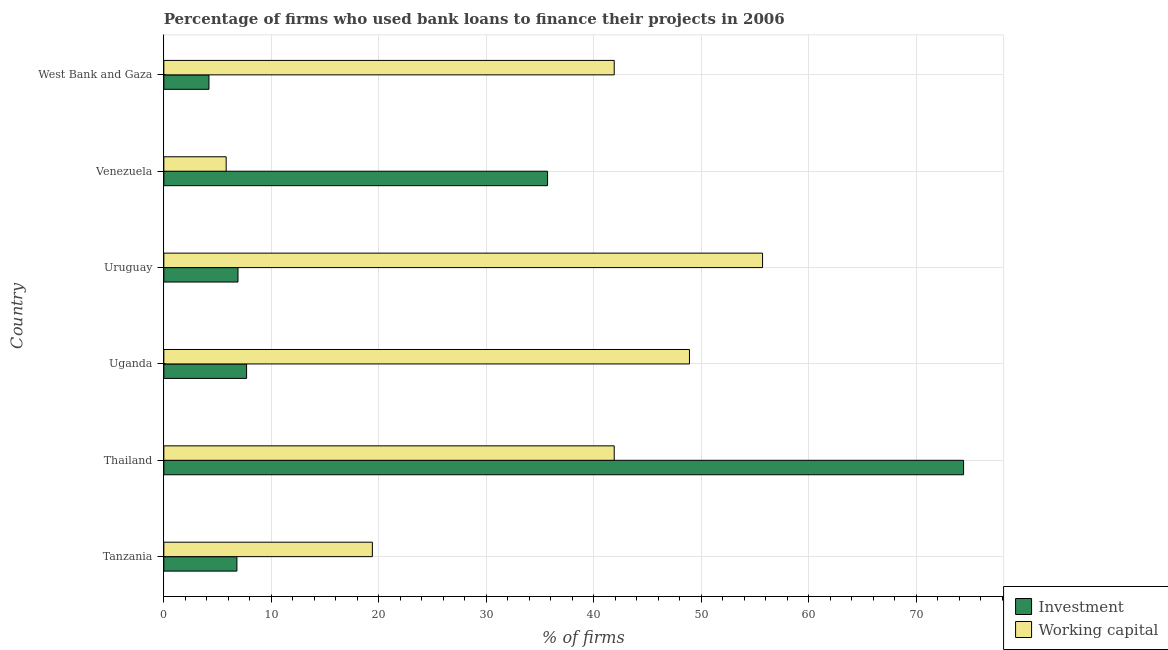Are the number of bars per tick equal to the number of legend labels?
Your answer should be very brief. Yes. How many bars are there on the 6th tick from the top?
Ensure brevity in your answer.  2. How many bars are there on the 2nd tick from the bottom?
Provide a succinct answer. 2. What is the label of the 4th group of bars from the top?
Your answer should be compact. Uganda. In how many cases, is the number of bars for a given country not equal to the number of legend labels?
Provide a short and direct response. 0. What is the percentage of firms using banks to finance investment in Thailand?
Your response must be concise. 74.4. Across all countries, what is the maximum percentage of firms using banks to finance working capital?
Your answer should be compact. 55.7. In which country was the percentage of firms using banks to finance working capital maximum?
Your answer should be very brief. Uruguay. In which country was the percentage of firms using banks to finance investment minimum?
Your response must be concise. West Bank and Gaza. What is the total percentage of firms using banks to finance investment in the graph?
Ensure brevity in your answer.  135.7. What is the difference between the percentage of firms using banks to finance investment in Thailand and that in West Bank and Gaza?
Provide a succinct answer. 70.2. What is the difference between the percentage of firms using banks to finance investment in Uruguay and the percentage of firms using banks to finance working capital in Thailand?
Your response must be concise. -35. What is the average percentage of firms using banks to finance investment per country?
Your answer should be very brief. 22.62. What is the difference between the percentage of firms using banks to finance working capital and percentage of firms using banks to finance investment in Uruguay?
Ensure brevity in your answer.  48.8. In how many countries, is the percentage of firms using banks to finance working capital greater than 20 %?
Provide a short and direct response. 4. What is the ratio of the percentage of firms using banks to finance working capital in Thailand to that in Venezuela?
Offer a terse response. 7.22. Is the percentage of firms using banks to finance working capital in Tanzania less than that in Uruguay?
Provide a succinct answer. Yes. Is the difference between the percentage of firms using banks to finance working capital in Tanzania and Thailand greater than the difference between the percentage of firms using banks to finance investment in Tanzania and Thailand?
Ensure brevity in your answer.  Yes. What is the difference between the highest and the second highest percentage of firms using banks to finance investment?
Your response must be concise. 38.7. What is the difference between the highest and the lowest percentage of firms using banks to finance working capital?
Your answer should be compact. 49.9. Is the sum of the percentage of firms using banks to finance working capital in Thailand and West Bank and Gaza greater than the maximum percentage of firms using banks to finance investment across all countries?
Make the answer very short. Yes. What does the 1st bar from the top in Tanzania represents?
Provide a short and direct response. Working capital. What does the 1st bar from the bottom in Tanzania represents?
Make the answer very short. Investment. Are all the bars in the graph horizontal?
Provide a short and direct response. Yes. Are the values on the major ticks of X-axis written in scientific E-notation?
Keep it short and to the point. No. Does the graph contain grids?
Keep it short and to the point. Yes. Where does the legend appear in the graph?
Your answer should be compact. Bottom right. How many legend labels are there?
Offer a very short reply. 2. How are the legend labels stacked?
Your answer should be compact. Vertical. What is the title of the graph?
Your answer should be compact. Percentage of firms who used bank loans to finance their projects in 2006. Does "Boys" appear as one of the legend labels in the graph?
Make the answer very short. No. What is the label or title of the X-axis?
Provide a succinct answer. % of firms. What is the label or title of the Y-axis?
Provide a succinct answer. Country. What is the % of firms of Investment in Tanzania?
Keep it short and to the point. 6.8. What is the % of firms of Investment in Thailand?
Your answer should be compact. 74.4. What is the % of firms of Working capital in Thailand?
Provide a succinct answer. 41.9. What is the % of firms of Working capital in Uganda?
Keep it short and to the point. 48.9. What is the % of firms of Working capital in Uruguay?
Your response must be concise. 55.7. What is the % of firms in Investment in Venezuela?
Keep it short and to the point. 35.7. What is the % of firms of Working capital in Venezuela?
Offer a very short reply. 5.8. What is the % of firms in Investment in West Bank and Gaza?
Offer a terse response. 4.2. What is the % of firms in Working capital in West Bank and Gaza?
Keep it short and to the point. 41.9. Across all countries, what is the maximum % of firms in Investment?
Make the answer very short. 74.4. Across all countries, what is the maximum % of firms in Working capital?
Your response must be concise. 55.7. Across all countries, what is the minimum % of firms in Working capital?
Provide a succinct answer. 5.8. What is the total % of firms of Investment in the graph?
Make the answer very short. 135.7. What is the total % of firms in Working capital in the graph?
Give a very brief answer. 213.6. What is the difference between the % of firms in Investment in Tanzania and that in Thailand?
Give a very brief answer. -67.6. What is the difference between the % of firms in Working capital in Tanzania and that in Thailand?
Keep it short and to the point. -22.5. What is the difference between the % of firms in Investment in Tanzania and that in Uganda?
Keep it short and to the point. -0.9. What is the difference between the % of firms of Working capital in Tanzania and that in Uganda?
Keep it short and to the point. -29.5. What is the difference between the % of firms of Investment in Tanzania and that in Uruguay?
Ensure brevity in your answer.  -0.1. What is the difference between the % of firms of Working capital in Tanzania and that in Uruguay?
Make the answer very short. -36.3. What is the difference between the % of firms in Investment in Tanzania and that in Venezuela?
Give a very brief answer. -28.9. What is the difference between the % of firms in Investment in Tanzania and that in West Bank and Gaza?
Your answer should be compact. 2.6. What is the difference between the % of firms of Working capital in Tanzania and that in West Bank and Gaza?
Keep it short and to the point. -22.5. What is the difference between the % of firms of Investment in Thailand and that in Uganda?
Your response must be concise. 66.7. What is the difference between the % of firms of Investment in Thailand and that in Uruguay?
Ensure brevity in your answer.  67.5. What is the difference between the % of firms of Investment in Thailand and that in Venezuela?
Provide a succinct answer. 38.7. What is the difference between the % of firms of Working capital in Thailand and that in Venezuela?
Provide a short and direct response. 36.1. What is the difference between the % of firms in Investment in Thailand and that in West Bank and Gaza?
Provide a short and direct response. 70.2. What is the difference between the % of firms of Working capital in Thailand and that in West Bank and Gaza?
Provide a short and direct response. 0. What is the difference between the % of firms in Investment in Uganda and that in Venezuela?
Make the answer very short. -28. What is the difference between the % of firms in Working capital in Uganda and that in Venezuela?
Provide a succinct answer. 43.1. What is the difference between the % of firms of Working capital in Uganda and that in West Bank and Gaza?
Ensure brevity in your answer.  7. What is the difference between the % of firms of Investment in Uruguay and that in Venezuela?
Ensure brevity in your answer.  -28.8. What is the difference between the % of firms in Working capital in Uruguay and that in Venezuela?
Ensure brevity in your answer.  49.9. What is the difference between the % of firms in Working capital in Uruguay and that in West Bank and Gaza?
Ensure brevity in your answer.  13.8. What is the difference between the % of firms of Investment in Venezuela and that in West Bank and Gaza?
Make the answer very short. 31.5. What is the difference between the % of firms of Working capital in Venezuela and that in West Bank and Gaza?
Offer a terse response. -36.1. What is the difference between the % of firms in Investment in Tanzania and the % of firms in Working capital in Thailand?
Offer a very short reply. -35.1. What is the difference between the % of firms in Investment in Tanzania and the % of firms in Working capital in Uganda?
Your answer should be very brief. -42.1. What is the difference between the % of firms in Investment in Tanzania and the % of firms in Working capital in Uruguay?
Make the answer very short. -48.9. What is the difference between the % of firms in Investment in Tanzania and the % of firms in Working capital in Venezuela?
Your answer should be very brief. 1. What is the difference between the % of firms in Investment in Tanzania and the % of firms in Working capital in West Bank and Gaza?
Your response must be concise. -35.1. What is the difference between the % of firms of Investment in Thailand and the % of firms of Working capital in Venezuela?
Give a very brief answer. 68.6. What is the difference between the % of firms of Investment in Thailand and the % of firms of Working capital in West Bank and Gaza?
Your answer should be very brief. 32.5. What is the difference between the % of firms of Investment in Uganda and the % of firms of Working capital in Uruguay?
Give a very brief answer. -48. What is the difference between the % of firms in Investment in Uganda and the % of firms in Working capital in Venezuela?
Offer a very short reply. 1.9. What is the difference between the % of firms in Investment in Uganda and the % of firms in Working capital in West Bank and Gaza?
Offer a very short reply. -34.2. What is the difference between the % of firms in Investment in Uruguay and the % of firms in Working capital in Venezuela?
Your answer should be compact. 1.1. What is the difference between the % of firms of Investment in Uruguay and the % of firms of Working capital in West Bank and Gaza?
Keep it short and to the point. -35. What is the difference between the % of firms in Investment in Venezuela and the % of firms in Working capital in West Bank and Gaza?
Make the answer very short. -6.2. What is the average % of firms of Investment per country?
Give a very brief answer. 22.62. What is the average % of firms of Working capital per country?
Give a very brief answer. 35.6. What is the difference between the % of firms of Investment and % of firms of Working capital in Thailand?
Provide a short and direct response. 32.5. What is the difference between the % of firms of Investment and % of firms of Working capital in Uganda?
Your answer should be very brief. -41.2. What is the difference between the % of firms of Investment and % of firms of Working capital in Uruguay?
Keep it short and to the point. -48.8. What is the difference between the % of firms in Investment and % of firms in Working capital in Venezuela?
Your answer should be compact. 29.9. What is the difference between the % of firms in Investment and % of firms in Working capital in West Bank and Gaza?
Offer a very short reply. -37.7. What is the ratio of the % of firms of Investment in Tanzania to that in Thailand?
Provide a short and direct response. 0.09. What is the ratio of the % of firms of Working capital in Tanzania to that in Thailand?
Your answer should be very brief. 0.46. What is the ratio of the % of firms in Investment in Tanzania to that in Uganda?
Provide a succinct answer. 0.88. What is the ratio of the % of firms of Working capital in Tanzania to that in Uganda?
Your response must be concise. 0.4. What is the ratio of the % of firms in Investment in Tanzania to that in Uruguay?
Provide a short and direct response. 0.99. What is the ratio of the % of firms in Working capital in Tanzania to that in Uruguay?
Your response must be concise. 0.35. What is the ratio of the % of firms in Investment in Tanzania to that in Venezuela?
Provide a short and direct response. 0.19. What is the ratio of the % of firms of Working capital in Tanzania to that in Venezuela?
Ensure brevity in your answer.  3.34. What is the ratio of the % of firms in Investment in Tanzania to that in West Bank and Gaza?
Provide a succinct answer. 1.62. What is the ratio of the % of firms in Working capital in Tanzania to that in West Bank and Gaza?
Offer a very short reply. 0.46. What is the ratio of the % of firms in Investment in Thailand to that in Uganda?
Offer a very short reply. 9.66. What is the ratio of the % of firms of Working capital in Thailand to that in Uganda?
Offer a very short reply. 0.86. What is the ratio of the % of firms in Investment in Thailand to that in Uruguay?
Offer a very short reply. 10.78. What is the ratio of the % of firms in Working capital in Thailand to that in Uruguay?
Offer a terse response. 0.75. What is the ratio of the % of firms of Investment in Thailand to that in Venezuela?
Offer a terse response. 2.08. What is the ratio of the % of firms in Working capital in Thailand to that in Venezuela?
Ensure brevity in your answer.  7.22. What is the ratio of the % of firms in Investment in Thailand to that in West Bank and Gaza?
Give a very brief answer. 17.71. What is the ratio of the % of firms in Working capital in Thailand to that in West Bank and Gaza?
Offer a very short reply. 1. What is the ratio of the % of firms of Investment in Uganda to that in Uruguay?
Keep it short and to the point. 1.12. What is the ratio of the % of firms in Working capital in Uganda to that in Uruguay?
Ensure brevity in your answer.  0.88. What is the ratio of the % of firms of Investment in Uganda to that in Venezuela?
Make the answer very short. 0.22. What is the ratio of the % of firms in Working capital in Uganda to that in Venezuela?
Make the answer very short. 8.43. What is the ratio of the % of firms in Investment in Uganda to that in West Bank and Gaza?
Give a very brief answer. 1.83. What is the ratio of the % of firms of Working capital in Uganda to that in West Bank and Gaza?
Provide a short and direct response. 1.17. What is the ratio of the % of firms in Investment in Uruguay to that in Venezuela?
Offer a terse response. 0.19. What is the ratio of the % of firms in Working capital in Uruguay to that in Venezuela?
Your answer should be very brief. 9.6. What is the ratio of the % of firms of Investment in Uruguay to that in West Bank and Gaza?
Your response must be concise. 1.64. What is the ratio of the % of firms in Working capital in Uruguay to that in West Bank and Gaza?
Provide a short and direct response. 1.33. What is the ratio of the % of firms in Working capital in Venezuela to that in West Bank and Gaza?
Provide a succinct answer. 0.14. What is the difference between the highest and the second highest % of firms of Investment?
Keep it short and to the point. 38.7. What is the difference between the highest and the lowest % of firms of Investment?
Offer a terse response. 70.2. What is the difference between the highest and the lowest % of firms in Working capital?
Offer a very short reply. 49.9. 